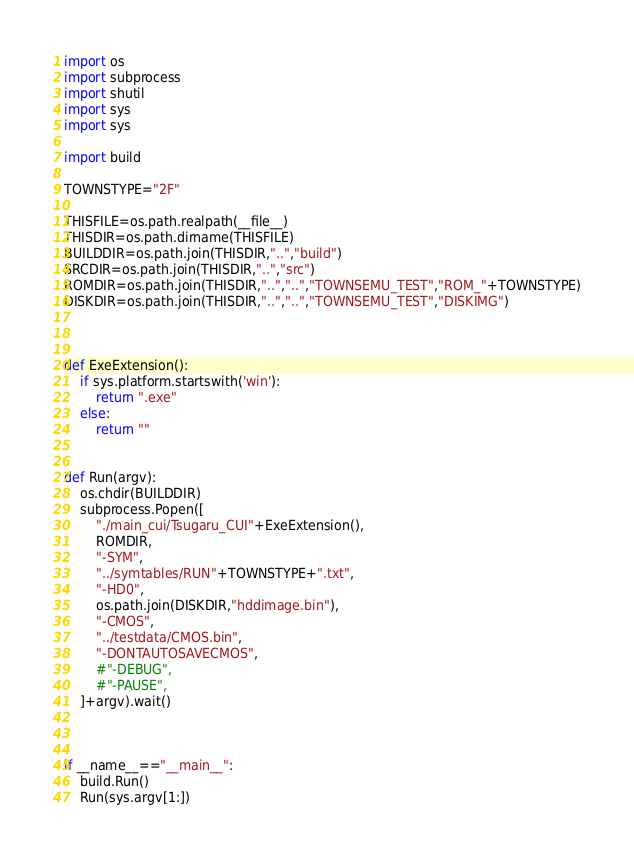Convert code to text. <code><loc_0><loc_0><loc_500><loc_500><_Python_>import os
import subprocess
import shutil
import sys
import sys

import build

TOWNSTYPE="2F"

THISFILE=os.path.realpath(__file__)
THISDIR=os.path.dirname(THISFILE)
BUILDDIR=os.path.join(THISDIR,"..","build")
SRCDIR=os.path.join(THISDIR,"..","src")
ROMDIR=os.path.join(THISDIR,"..","..","TOWNSEMU_TEST","ROM_"+TOWNSTYPE)
DISKDIR=os.path.join(THISDIR,"..","..","TOWNSEMU_TEST","DISKIMG")



def ExeExtension():
	if sys.platform.startswith('win'):
		return ".exe"
	else:
		return ""


def Run(argv):
	os.chdir(BUILDDIR)
	subprocess.Popen([
		"./main_cui/Tsugaru_CUI"+ExeExtension(),
		ROMDIR,
		"-SYM",
		"../symtables/RUN"+TOWNSTYPE+".txt",
		"-HD0",
		os.path.join(DISKDIR,"hddimage.bin"),
		"-CMOS",
		"../testdata/CMOS.bin",
		"-DONTAUTOSAVECMOS",
		#"-DEBUG",
		#"-PAUSE",
	]+argv).wait()



if __name__=="__main__":
	build.Run()
	Run(sys.argv[1:])
</code> 